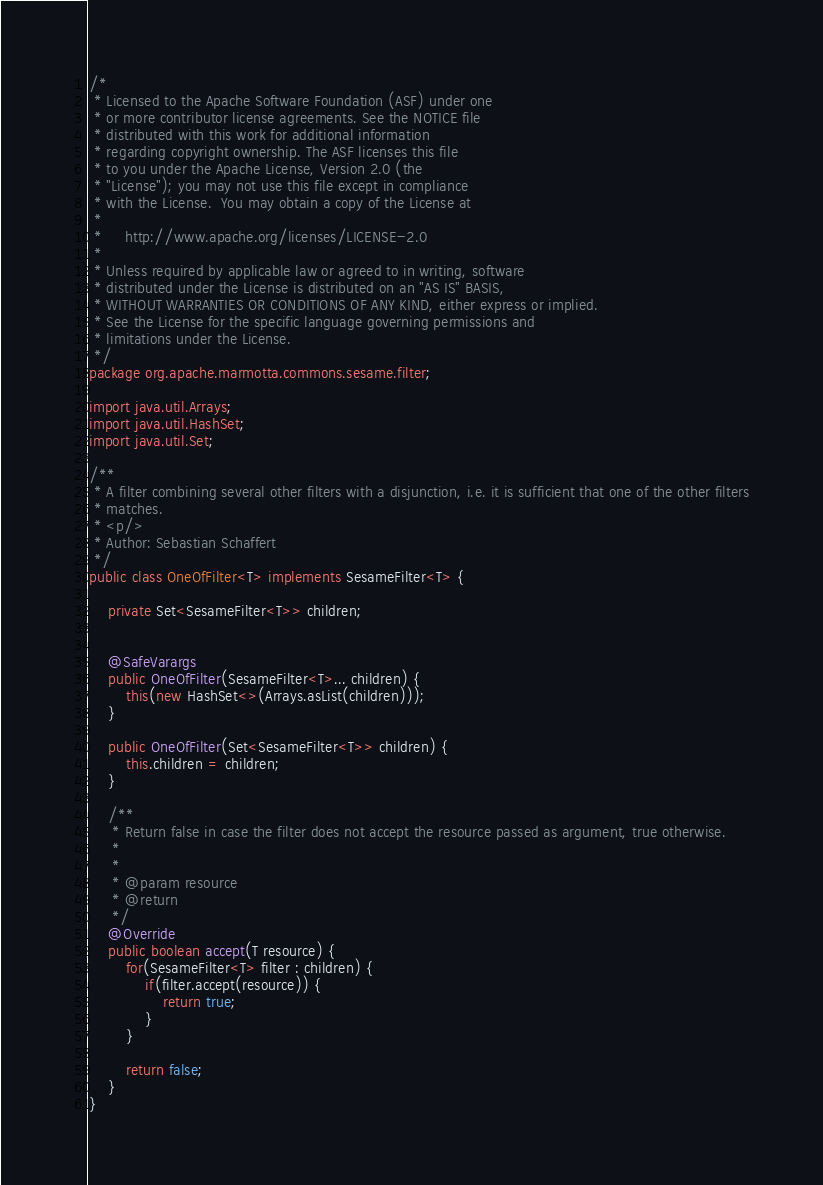Convert code to text. <code><loc_0><loc_0><loc_500><loc_500><_Java_>/*
 * Licensed to the Apache Software Foundation (ASF) under one
 * or more contributor license agreements. See the NOTICE file
 * distributed with this work for additional information
 * regarding copyright ownership. The ASF licenses this file
 * to you under the Apache License, Version 2.0 (the
 * "License"); you may not use this file except in compliance
 * with the License.  You may obtain a copy of the License at
 *
 *     http://www.apache.org/licenses/LICENSE-2.0
 *
 * Unless required by applicable law or agreed to in writing, software
 * distributed under the License is distributed on an "AS IS" BASIS,
 * WITHOUT WARRANTIES OR CONDITIONS OF ANY KIND, either express or implied.
 * See the License for the specific language governing permissions and
 * limitations under the License.
 */
package org.apache.marmotta.commons.sesame.filter;

import java.util.Arrays;
import java.util.HashSet;
import java.util.Set;

/**
 * A filter combining several other filters with a disjunction, i.e. it is sufficient that one of the other filters
 * matches.
 * <p/>
 * Author: Sebastian Schaffert
 */
public class OneOfFilter<T> implements SesameFilter<T> {

    private Set<SesameFilter<T>> children;


    @SafeVarargs
    public OneOfFilter(SesameFilter<T>... children) {
        this(new HashSet<>(Arrays.asList(children)));
    }

    public OneOfFilter(Set<SesameFilter<T>> children) {
        this.children = children;
    }

    /**
     * Return false in case the filter does not accept the resource passed as argument, true otherwise.
     *
     *
     * @param resource
     * @return
     */
    @Override
    public boolean accept(T resource) {
        for(SesameFilter<T> filter : children) {
            if(filter.accept(resource)) {
                return true;
            }
        }

        return false;
    }
}
</code> 